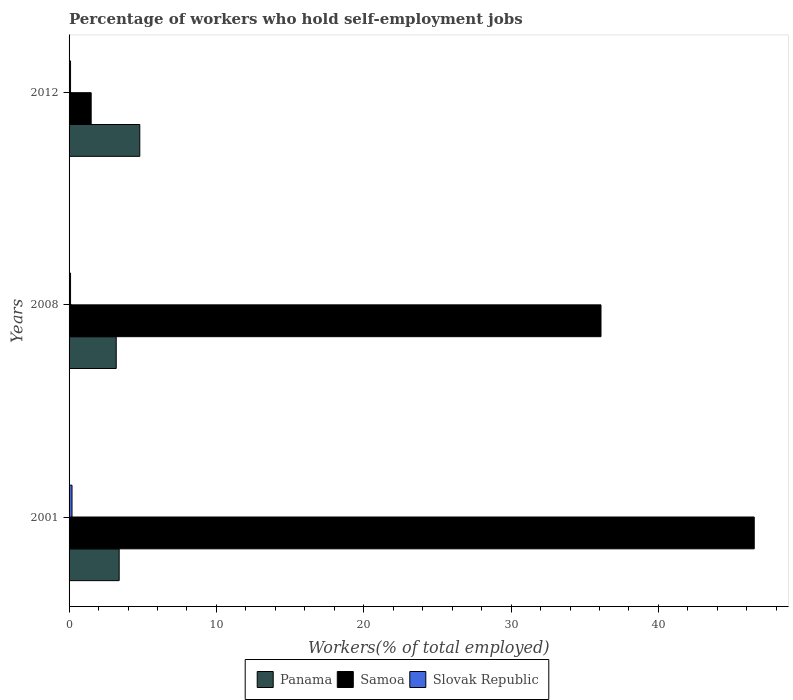Are the number of bars on each tick of the Y-axis equal?
Keep it short and to the point. Yes. How many bars are there on the 3rd tick from the bottom?
Provide a succinct answer. 3. What is the label of the 1st group of bars from the top?
Provide a succinct answer. 2012. What is the percentage of self-employed workers in Panama in 2012?
Your response must be concise. 4.8. Across all years, what is the maximum percentage of self-employed workers in Samoa?
Provide a short and direct response. 46.5. Across all years, what is the minimum percentage of self-employed workers in Slovak Republic?
Offer a very short reply. 0.1. In which year was the percentage of self-employed workers in Panama maximum?
Your response must be concise. 2012. In which year was the percentage of self-employed workers in Slovak Republic minimum?
Offer a very short reply. 2008. What is the total percentage of self-employed workers in Samoa in the graph?
Keep it short and to the point. 84.1. What is the difference between the percentage of self-employed workers in Samoa in 2008 and that in 2012?
Offer a terse response. 34.6. What is the difference between the percentage of self-employed workers in Slovak Republic in 2008 and the percentage of self-employed workers in Samoa in 2012?
Make the answer very short. -1.4. What is the average percentage of self-employed workers in Slovak Republic per year?
Provide a succinct answer. 0.13. In the year 2008, what is the difference between the percentage of self-employed workers in Panama and percentage of self-employed workers in Samoa?
Ensure brevity in your answer.  -32.9. In how many years, is the percentage of self-employed workers in Samoa greater than 26 %?
Keep it short and to the point. 2. What is the difference between the highest and the second highest percentage of self-employed workers in Samoa?
Your answer should be compact. 10.4. In how many years, is the percentage of self-employed workers in Slovak Republic greater than the average percentage of self-employed workers in Slovak Republic taken over all years?
Offer a terse response. 1. What does the 3rd bar from the top in 2012 represents?
Make the answer very short. Panama. What does the 1st bar from the bottom in 2001 represents?
Offer a very short reply. Panama. How many bars are there?
Your response must be concise. 9. How many years are there in the graph?
Your response must be concise. 3. What is the difference between two consecutive major ticks on the X-axis?
Make the answer very short. 10. Are the values on the major ticks of X-axis written in scientific E-notation?
Your answer should be very brief. No. Does the graph contain grids?
Make the answer very short. No. Where does the legend appear in the graph?
Offer a very short reply. Bottom center. How are the legend labels stacked?
Make the answer very short. Horizontal. What is the title of the graph?
Offer a very short reply. Percentage of workers who hold self-employment jobs. Does "Slovenia" appear as one of the legend labels in the graph?
Keep it short and to the point. No. What is the label or title of the X-axis?
Provide a succinct answer. Workers(% of total employed). What is the Workers(% of total employed) of Panama in 2001?
Your response must be concise. 3.4. What is the Workers(% of total employed) of Samoa in 2001?
Your answer should be very brief. 46.5. What is the Workers(% of total employed) of Slovak Republic in 2001?
Ensure brevity in your answer.  0.2. What is the Workers(% of total employed) in Panama in 2008?
Make the answer very short. 3.2. What is the Workers(% of total employed) of Samoa in 2008?
Make the answer very short. 36.1. What is the Workers(% of total employed) in Slovak Republic in 2008?
Ensure brevity in your answer.  0.1. What is the Workers(% of total employed) of Panama in 2012?
Provide a short and direct response. 4.8. What is the Workers(% of total employed) in Samoa in 2012?
Provide a succinct answer. 1.5. What is the Workers(% of total employed) of Slovak Republic in 2012?
Provide a short and direct response. 0.1. Across all years, what is the maximum Workers(% of total employed) in Panama?
Keep it short and to the point. 4.8. Across all years, what is the maximum Workers(% of total employed) in Samoa?
Make the answer very short. 46.5. Across all years, what is the maximum Workers(% of total employed) in Slovak Republic?
Ensure brevity in your answer.  0.2. Across all years, what is the minimum Workers(% of total employed) in Panama?
Provide a succinct answer. 3.2. Across all years, what is the minimum Workers(% of total employed) in Samoa?
Ensure brevity in your answer.  1.5. Across all years, what is the minimum Workers(% of total employed) of Slovak Republic?
Your answer should be compact. 0.1. What is the total Workers(% of total employed) in Panama in the graph?
Your answer should be compact. 11.4. What is the total Workers(% of total employed) of Samoa in the graph?
Ensure brevity in your answer.  84.1. What is the total Workers(% of total employed) in Slovak Republic in the graph?
Provide a short and direct response. 0.4. What is the difference between the Workers(% of total employed) of Samoa in 2001 and that in 2008?
Provide a succinct answer. 10.4. What is the difference between the Workers(% of total employed) in Slovak Republic in 2001 and that in 2008?
Offer a terse response. 0.1. What is the difference between the Workers(% of total employed) of Panama in 2001 and that in 2012?
Ensure brevity in your answer.  -1.4. What is the difference between the Workers(% of total employed) in Samoa in 2001 and that in 2012?
Ensure brevity in your answer.  45. What is the difference between the Workers(% of total employed) of Panama in 2008 and that in 2012?
Provide a short and direct response. -1.6. What is the difference between the Workers(% of total employed) in Samoa in 2008 and that in 2012?
Keep it short and to the point. 34.6. What is the difference between the Workers(% of total employed) in Panama in 2001 and the Workers(% of total employed) in Samoa in 2008?
Provide a succinct answer. -32.7. What is the difference between the Workers(% of total employed) of Panama in 2001 and the Workers(% of total employed) of Slovak Republic in 2008?
Make the answer very short. 3.3. What is the difference between the Workers(% of total employed) in Samoa in 2001 and the Workers(% of total employed) in Slovak Republic in 2008?
Make the answer very short. 46.4. What is the difference between the Workers(% of total employed) in Samoa in 2001 and the Workers(% of total employed) in Slovak Republic in 2012?
Your answer should be very brief. 46.4. What is the difference between the Workers(% of total employed) of Panama in 2008 and the Workers(% of total employed) of Samoa in 2012?
Give a very brief answer. 1.7. What is the difference between the Workers(% of total employed) of Panama in 2008 and the Workers(% of total employed) of Slovak Republic in 2012?
Offer a terse response. 3.1. What is the average Workers(% of total employed) of Panama per year?
Your answer should be compact. 3.8. What is the average Workers(% of total employed) in Samoa per year?
Offer a very short reply. 28.03. What is the average Workers(% of total employed) in Slovak Republic per year?
Your answer should be very brief. 0.13. In the year 2001, what is the difference between the Workers(% of total employed) in Panama and Workers(% of total employed) in Samoa?
Your response must be concise. -43.1. In the year 2001, what is the difference between the Workers(% of total employed) in Samoa and Workers(% of total employed) in Slovak Republic?
Ensure brevity in your answer.  46.3. In the year 2008, what is the difference between the Workers(% of total employed) of Panama and Workers(% of total employed) of Samoa?
Provide a short and direct response. -32.9. In the year 2008, what is the difference between the Workers(% of total employed) in Samoa and Workers(% of total employed) in Slovak Republic?
Make the answer very short. 36. In the year 2012, what is the difference between the Workers(% of total employed) of Panama and Workers(% of total employed) of Samoa?
Your response must be concise. 3.3. In the year 2012, what is the difference between the Workers(% of total employed) of Samoa and Workers(% of total employed) of Slovak Republic?
Offer a terse response. 1.4. What is the ratio of the Workers(% of total employed) in Samoa in 2001 to that in 2008?
Offer a very short reply. 1.29. What is the ratio of the Workers(% of total employed) in Slovak Republic in 2001 to that in 2008?
Your answer should be compact. 2. What is the ratio of the Workers(% of total employed) of Panama in 2001 to that in 2012?
Make the answer very short. 0.71. What is the ratio of the Workers(% of total employed) in Samoa in 2008 to that in 2012?
Offer a terse response. 24.07. What is the ratio of the Workers(% of total employed) of Slovak Republic in 2008 to that in 2012?
Offer a terse response. 1. What is the difference between the highest and the second highest Workers(% of total employed) of Samoa?
Your response must be concise. 10.4. What is the difference between the highest and the second highest Workers(% of total employed) in Slovak Republic?
Keep it short and to the point. 0.1. What is the difference between the highest and the lowest Workers(% of total employed) of Samoa?
Provide a succinct answer. 45. What is the difference between the highest and the lowest Workers(% of total employed) of Slovak Republic?
Give a very brief answer. 0.1. 